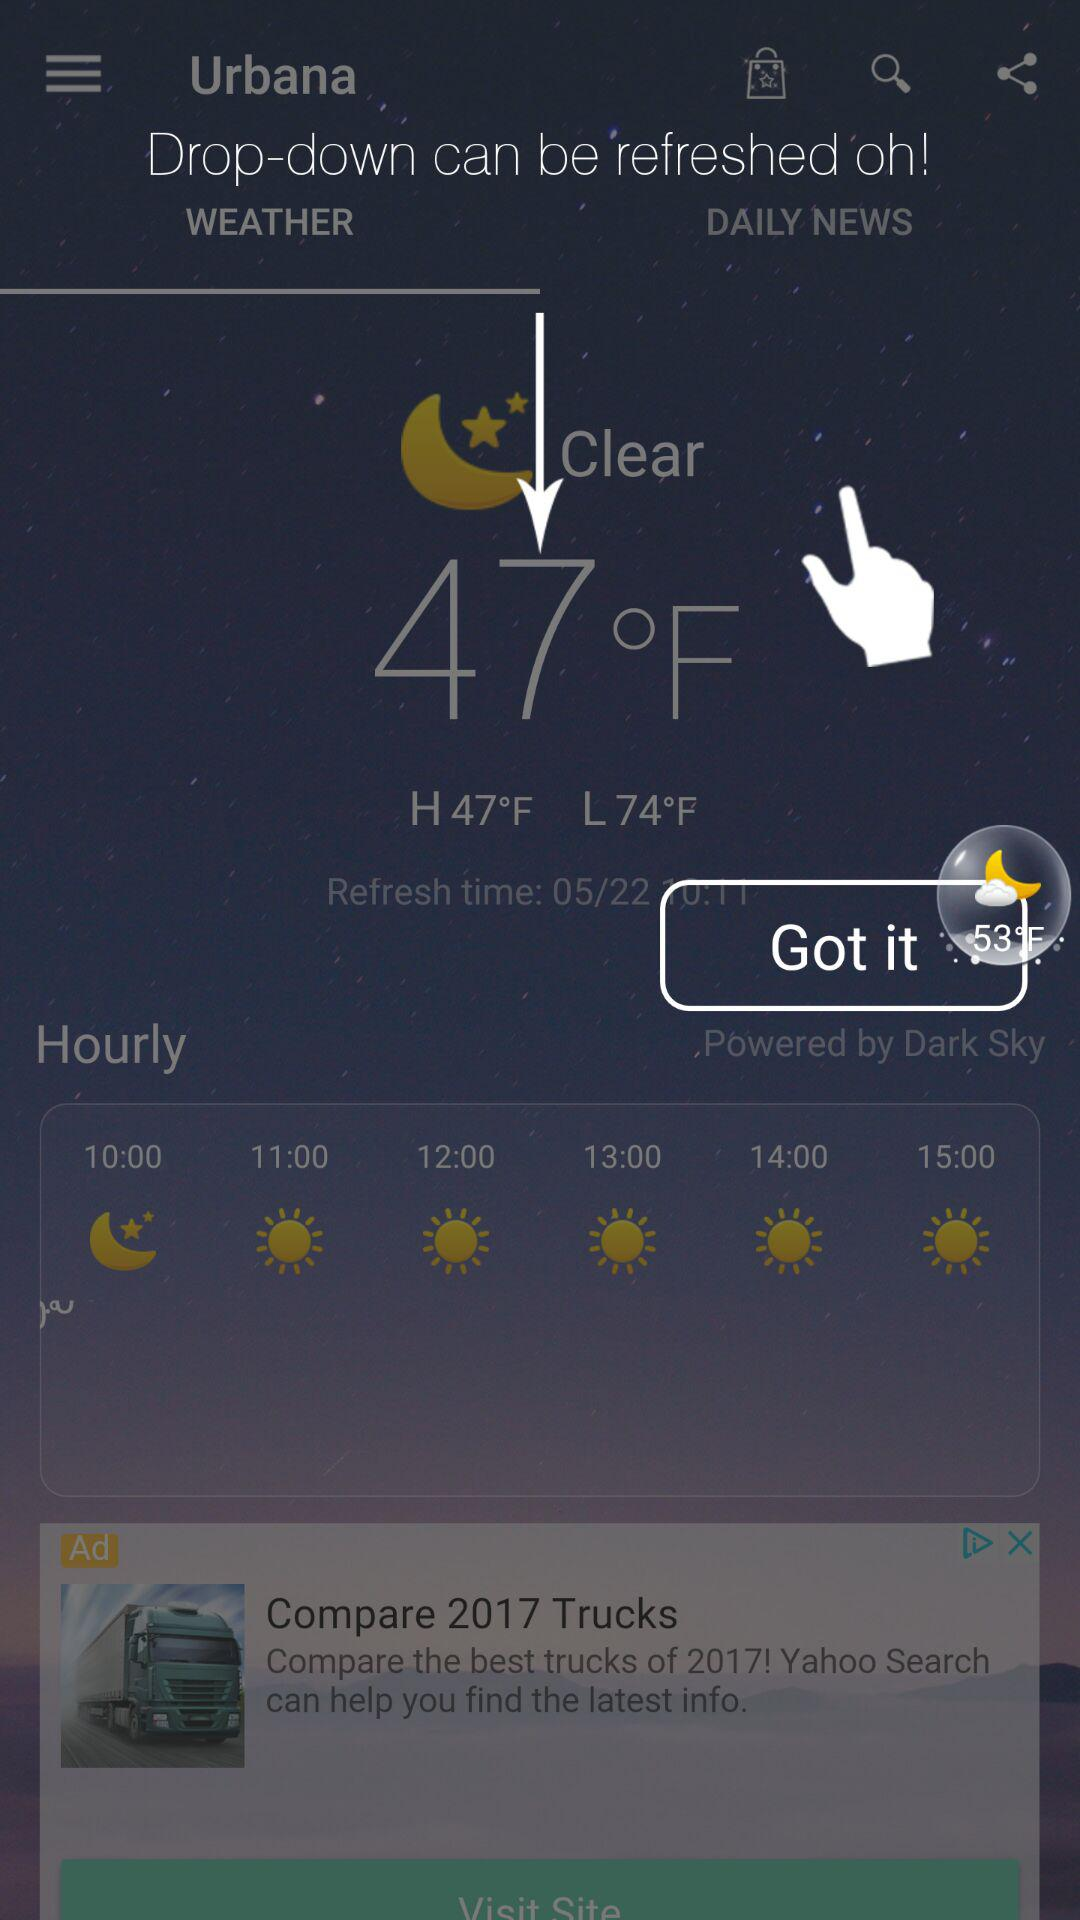How many hours are there between 10:00 and 15:00?
Answer the question using a single word or phrase. 5 